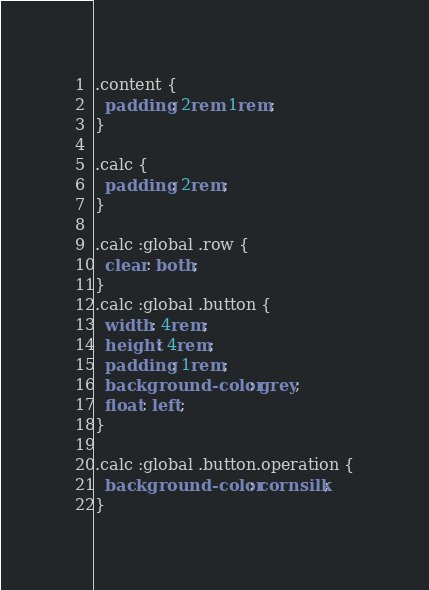Convert code to text. <code><loc_0><loc_0><loc_500><loc_500><_CSS_>.content {
  padding: 2rem 1rem;
}

.calc {
  padding: 2rem;
}

.calc :global .row {
  clear: both;
}
.calc :global .button {
  width: 4rem;
  height: 4rem;
  padding: 1rem;
  background-color: grey;
  float: left;
}

.calc :global .button.operation {
  background-color: cornsilk;
}
</code> 